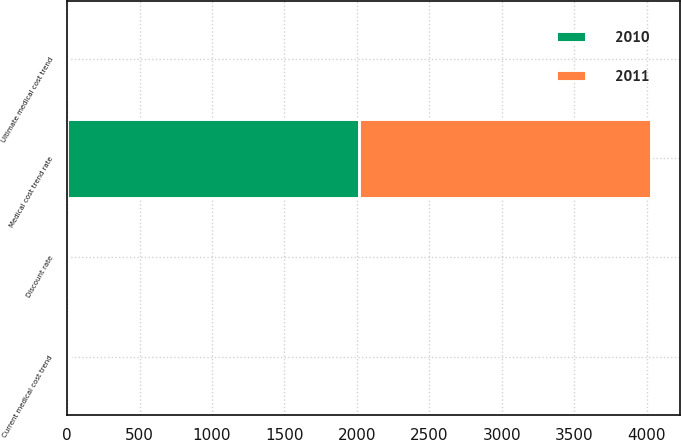<chart> <loc_0><loc_0><loc_500><loc_500><stacked_bar_chart><ecel><fcel>Discount rate<fcel>Current medical cost trend<fcel>Ultimate medical cost trend<fcel>Medical cost trend rate<nl><fcel>2010<fcel>5.5<fcel>8<fcel>4.75<fcel>2016<nl><fcel>2011<fcel>6.1<fcel>9<fcel>4.75<fcel>2016<nl></chart> 